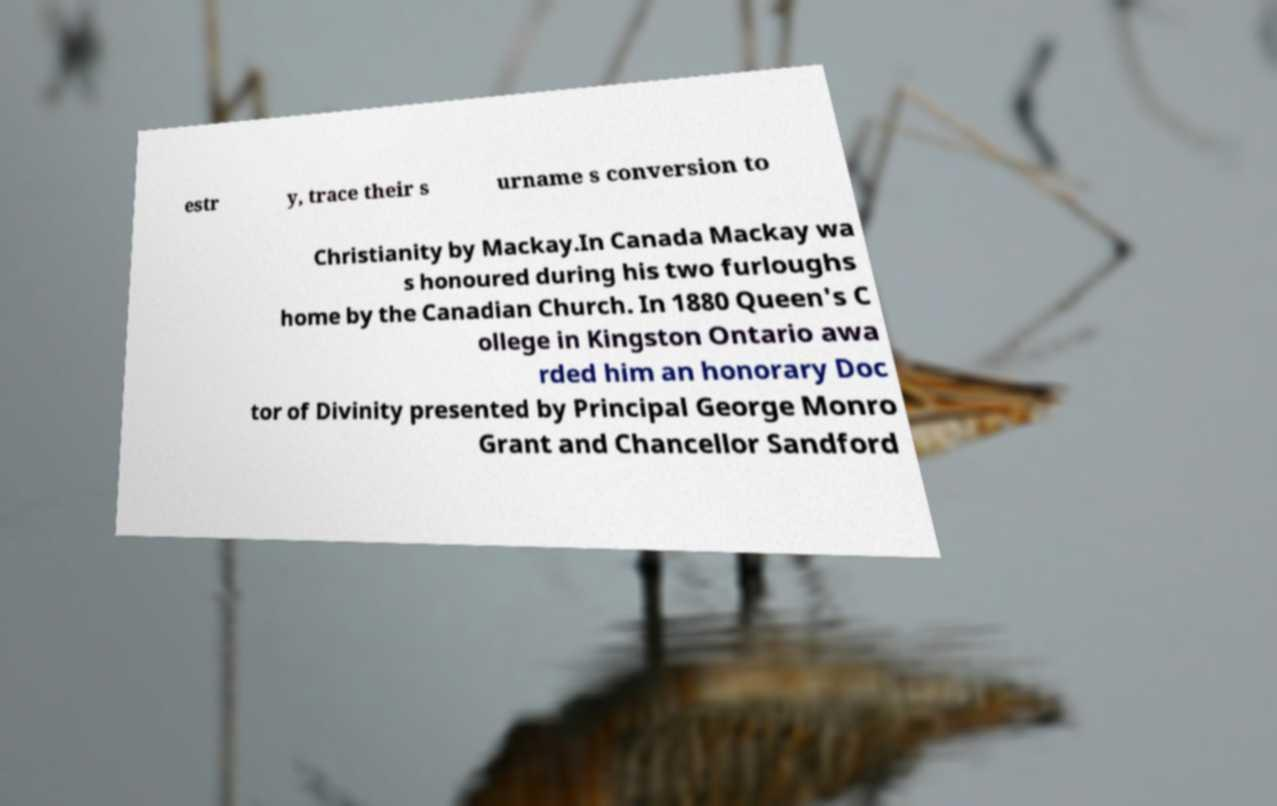Could you extract and type out the text from this image? estr y, trace their s urname s conversion to Christianity by Mackay.In Canada Mackay wa s honoured during his two furloughs home by the Canadian Church. In 1880 Queen's C ollege in Kingston Ontario awa rded him an honorary Doc tor of Divinity presented by Principal George Monro Grant and Chancellor Sandford 